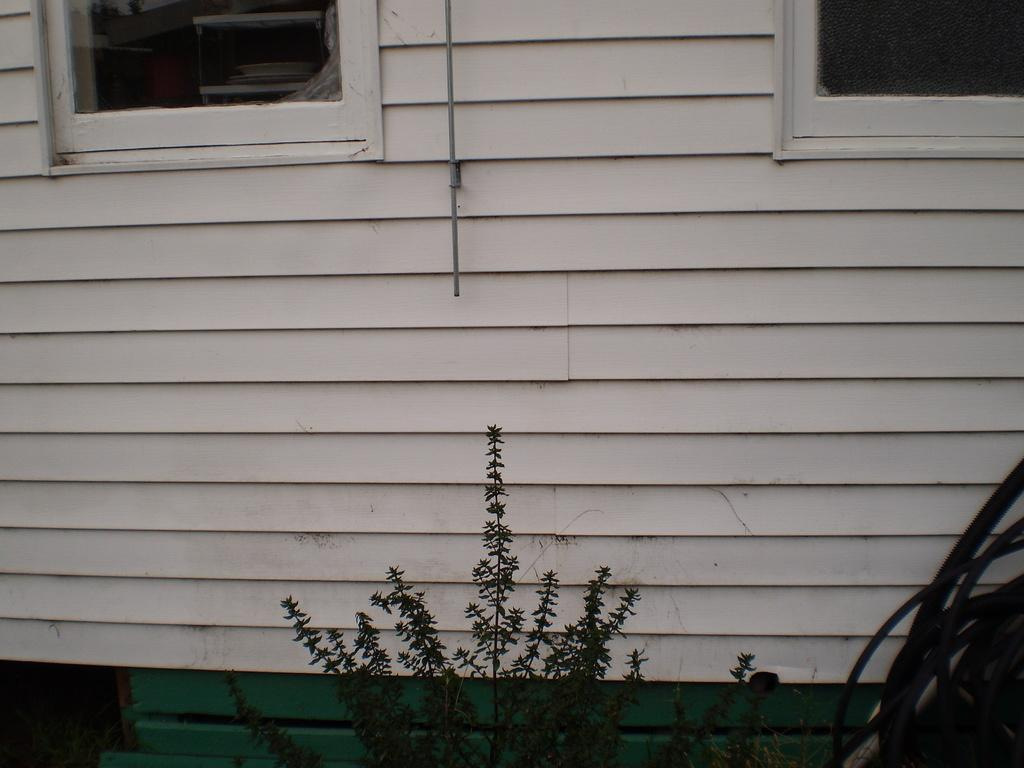What is located in the front of the image? There is a plant in the front of the image. What can be seen on the right side of the image? There are black pipes on the right side of the image. What is visible in the background of the image? There is a building in the background of the image. How many windows are visible on the building? The building has two windows. What is the taste of the birthday cake in the image? There is no birthday cake present in the image. What is the chance of winning a prize in the image? There is no mention of a prize or a chance to win in the image. 